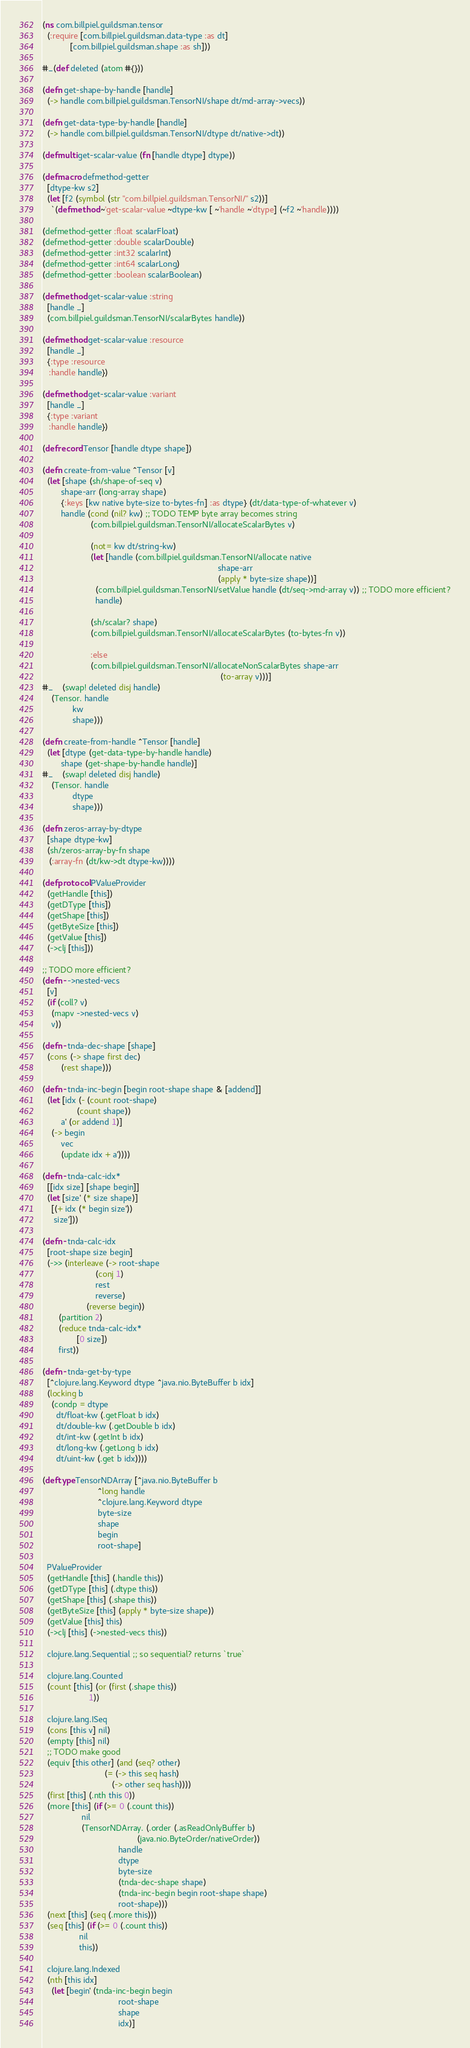Convert code to text. <code><loc_0><loc_0><loc_500><loc_500><_Clojure_>(ns com.billpiel.guildsman.tensor
  (:require [com.billpiel.guildsman.data-type :as dt]
            [com.billpiel.guildsman.shape :as sh]))

#_(def deleted (atom #{}))

(defn get-shape-by-handle [handle]
  (-> handle com.billpiel.guildsman.TensorNI/shape dt/md-array->vecs))

(defn get-data-type-by-handle [handle]
  (-> handle com.billpiel.guildsman.TensorNI/dtype dt/native->dt))

(defmulti get-scalar-value (fn [handle dtype] dtype))

(defmacro defmethod-getter
  [dtype-kw s2]
  (let [f2 (symbol (str "com.billpiel.guildsman.TensorNI/" s2))]
    `(defmethod ~'get-scalar-value ~dtype-kw [ ~'handle ~'dtype] (~f2 ~'handle))))

(defmethod-getter :float scalarFloat)
(defmethod-getter :double scalarDouble)
(defmethod-getter :int32 scalarInt)
(defmethod-getter :int64 scalarLong)
(defmethod-getter :boolean scalarBoolean)

(defmethod get-scalar-value :string
  [handle _]
  (com.billpiel.guildsman.TensorNI/scalarBytes handle))

(defmethod get-scalar-value :resource
  [handle _]
  {:type :resource
   :handle handle})

(defmethod get-scalar-value :variant
  [handle _]
  {:type :variant
   :handle handle})

(defrecord Tensor [handle dtype shape])

(defn create-from-value ^Tensor [v]
  (let [shape (sh/shape-of-seq v)
        shape-arr (long-array shape)
        {:keys [kw native byte-size to-bytes-fn] :as dtype} (dt/data-type-of-whatever v)
        handle (cond (nil? kw) ;; TODO TEMP byte array becomes string
                     (com.billpiel.guildsman.TensorNI/allocateScalarBytes v)

                     (not= kw dt/string-kw)
                     (let [handle (com.billpiel.guildsman.TensorNI/allocate native
                                                                            shape-arr
                                                                            (apply * byte-size shape))]
                       (com.billpiel.guildsman.TensorNI/setValue handle (dt/seq->md-array v)) ;; TODO more efficient?
                       handle)

                     (sh/scalar? shape)
                     (com.billpiel.guildsman.TensorNI/allocateScalarBytes (to-bytes-fn v))

                     :else
                     (com.billpiel.guildsman.TensorNI/allocateNonScalarBytes shape-arr
                                                                             (to-array v)))]
#_    (swap! deleted disj handle)
    (Tensor. handle
             kw
             shape)))

(defn create-from-handle ^Tensor [handle]
  (let [dtype (get-data-type-by-handle handle)
        shape (get-shape-by-handle handle)]
#_    (swap! deleted disj handle)
    (Tensor. handle
             dtype
             shape)))

(defn zeros-array-by-dtype
  [shape dtype-kw]
  (sh/zeros-array-by-fn shape
   (:array-fn (dt/kw->dt dtype-kw))))

(defprotocol PValueProvider
  (getHandle [this])
  (getDType [this])
  (getShape [this])
  (getByteSize [this])
  (getValue [this])
  (->clj [this]))

;; TODO more efficient?
(defn- ->nested-vecs
  [v]
  (if (coll? v)
    (mapv ->nested-vecs v)
    v))

(defn- tnda-dec-shape [shape]
  (cons (-> shape first dec)
        (rest shape)))

(defn- tnda-inc-begin [begin root-shape shape & [addend]]
  (let [idx (- (count root-shape)
               (count shape))
        a' (or addend 1)]
    (-> begin
        vec
        (update idx + a'))))

(defn- tnda-calc-idx*
  [[idx size] [shape begin]]
  (let [size' (* size shape)]
    [(+ idx (* begin size'))
     size']))

(defn- tnda-calc-idx
  [root-shape size begin]
  (->> (interleave (-> root-shape
                       (conj 1)
                       rest
                       reverse)
                   (reverse begin))
       (partition 2)
       (reduce tnda-calc-idx*
               [0 size])
       first))

(defn- tnda-get-by-type
  [^clojure.lang.Keyword dtype ^java.nio.ByteBuffer b idx]
  (locking b
    (condp = dtype
      dt/float-kw (.getFloat b idx)
      dt/double-kw (.getDouble b idx)
      dt/int-kw (.getInt b idx)
      dt/long-kw (.getLong b idx)
      dt/uint-kw (.get b idx))))

(deftype TensorNDArray [^java.nio.ByteBuffer b
                        ^long handle
                        ^clojure.lang.Keyword dtype
                        byte-size
                        shape
                        begin
                        root-shape]

  PValueProvider
  (getHandle [this] (.handle this))
  (getDType [this] (.dtype this))
  (getShape [this] (.shape this))
  (getByteSize [this] (apply * byte-size shape))
  (getValue [this] this)
  (->clj [this] (->nested-vecs this))

  clojure.lang.Sequential ;; so sequential? returns `true`
  
  clojure.lang.Counted
  (count [this] (or (first (.shape this))
                    1))

  clojure.lang.ISeq
  (cons [this v] nil)
  (empty [this] nil)
  ;; TODO make good
  (equiv [this other] (and (seq? other)
                           (= (-> this seq hash)
                              (-> other seq hash))))
  (first [this] (.nth this 0))
  (more [this] (if (>= 0 (.count this))
                 nil
                 (TensorNDArray. (.order (.asReadOnlyBuffer b)
                                         (java.nio.ByteOrder/nativeOrder))
                                 handle
                                 dtype
                                 byte-size
                                 (tnda-dec-shape shape)
                                 (tnda-inc-begin begin root-shape shape)
                                 root-shape)))
  (next [this] (seq (.more this)))
  (seq [this] (if (>= 0 (.count this))
                nil
                this))

  clojure.lang.Indexed
  (nth [this idx]
    (let [begin' (tnda-inc-begin begin
                                 root-shape
                                 shape
                                 idx)]</code> 